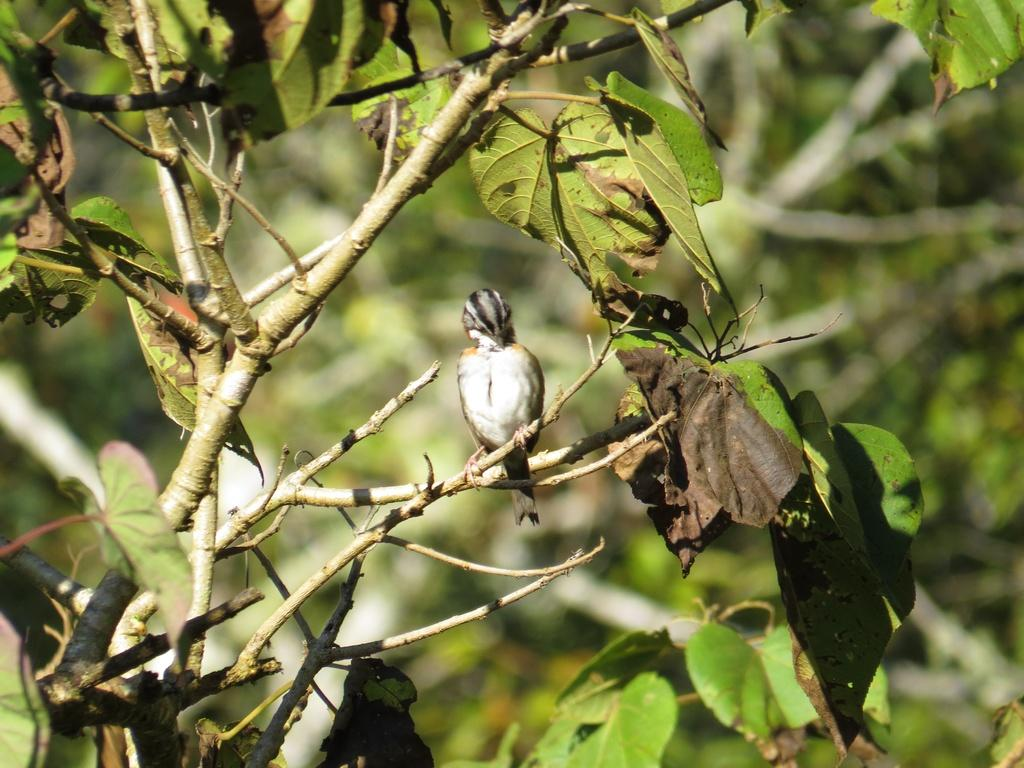What type of animal can be seen in the image? There is a bird in the image. Where is the bird located? The bird is on a tree. What type of wax is being used by the bird to build its nest in the image? There is no indication in the image that the bird is building a nest or using wax for any purpose. 